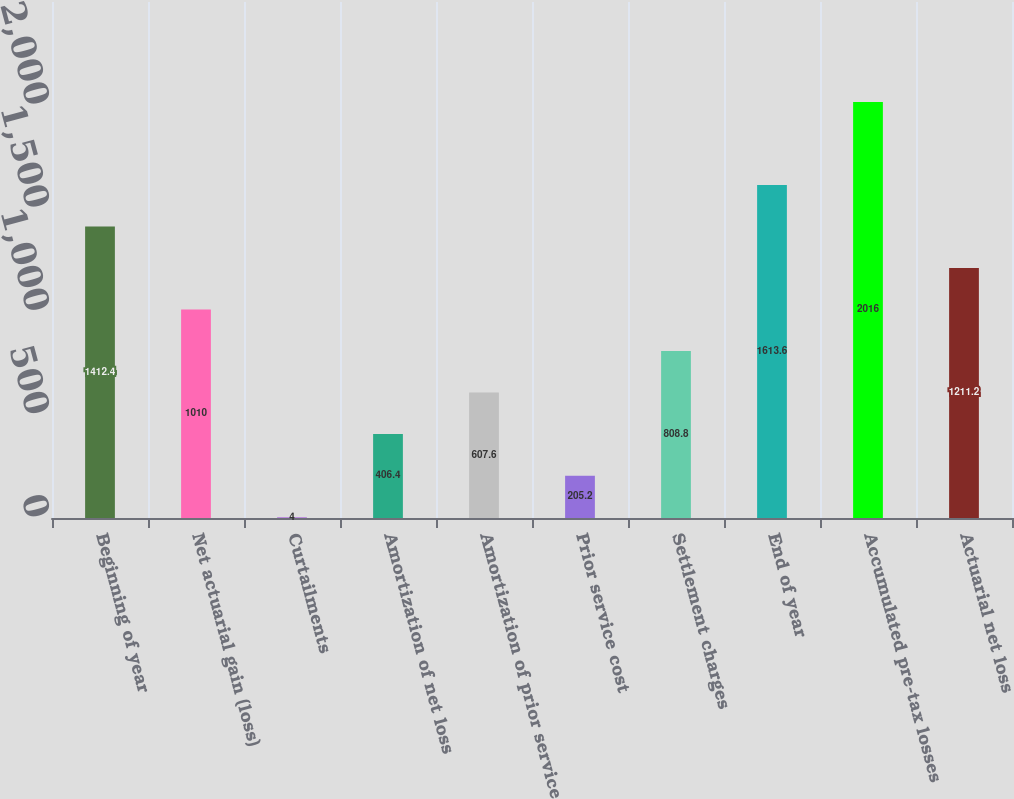Convert chart. <chart><loc_0><loc_0><loc_500><loc_500><bar_chart><fcel>Beginning of year<fcel>Net actuarial gain (loss)<fcel>Curtailments<fcel>Amortization of net loss<fcel>Amortization of prior service<fcel>Prior service cost<fcel>Settlement charges<fcel>End of year<fcel>Accumulated pre-tax losses<fcel>Actuarial net loss<nl><fcel>1412.4<fcel>1010<fcel>4<fcel>406.4<fcel>607.6<fcel>205.2<fcel>808.8<fcel>1613.6<fcel>2016<fcel>1211.2<nl></chart> 